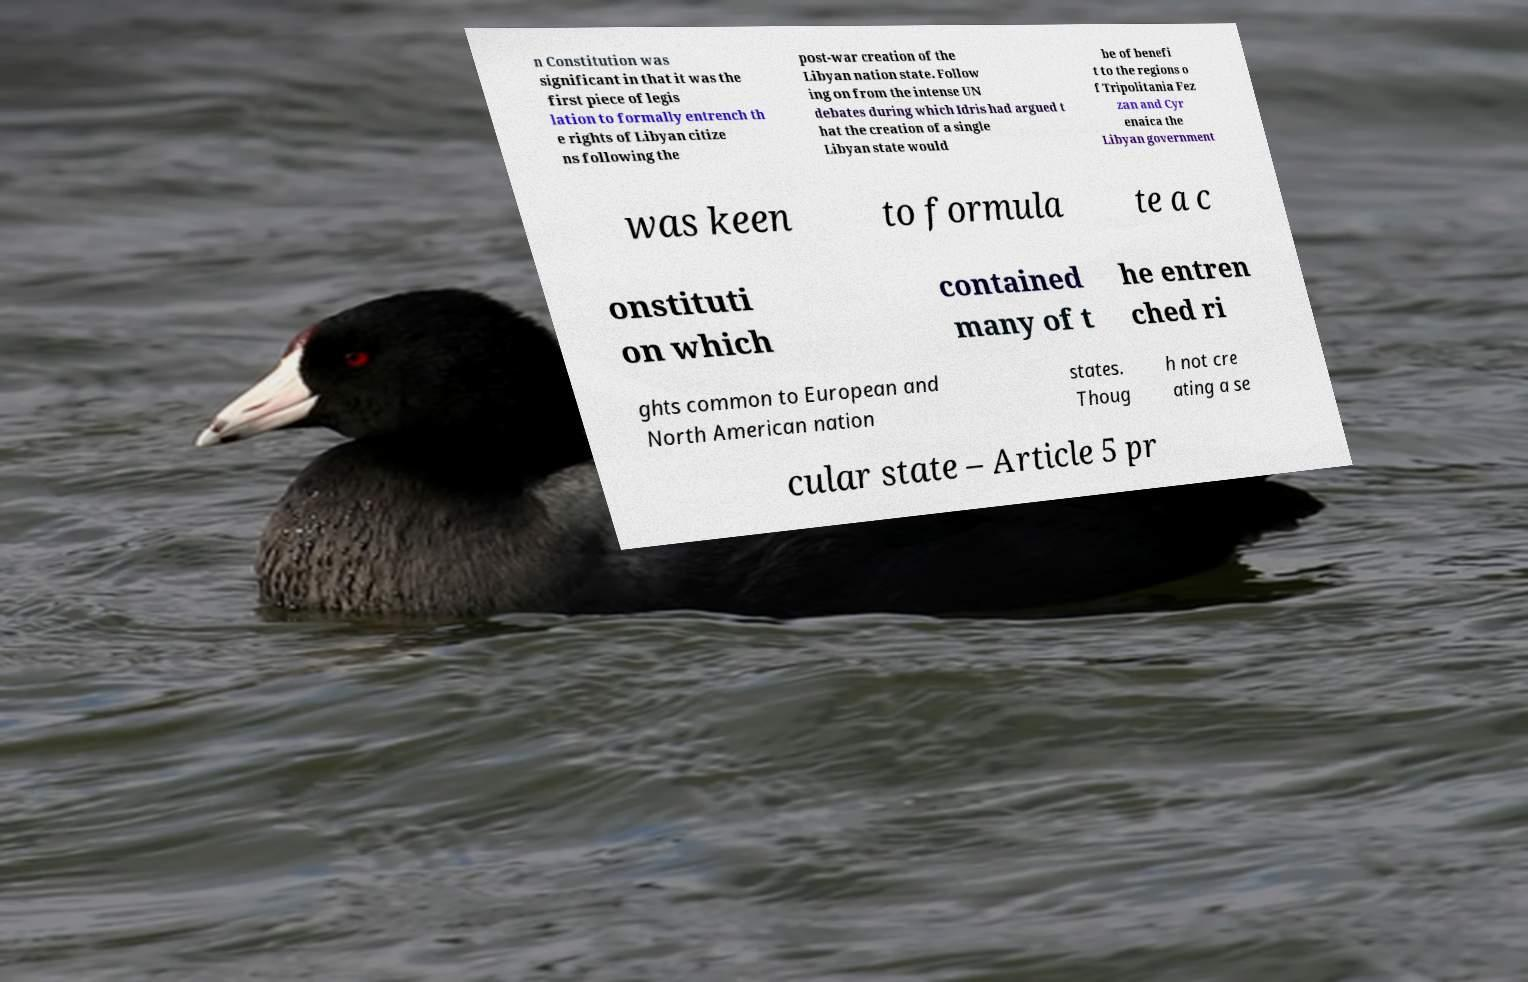Please read and relay the text visible in this image. What does it say? n Constitution was significant in that it was the first piece of legis lation to formally entrench th e rights of Libyan citize ns following the post-war creation of the Libyan nation state. Follow ing on from the intense UN debates during which Idris had argued t hat the creation of a single Libyan state would be of benefi t to the regions o f Tripolitania Fez zan and Cyr enaica the Libyan government was keen to formula te a c onstituti on which contained many of t he entren ched ri ghts common to European and North American nation states. Thoug h not cre ating a se cular state – Article 5 pr 